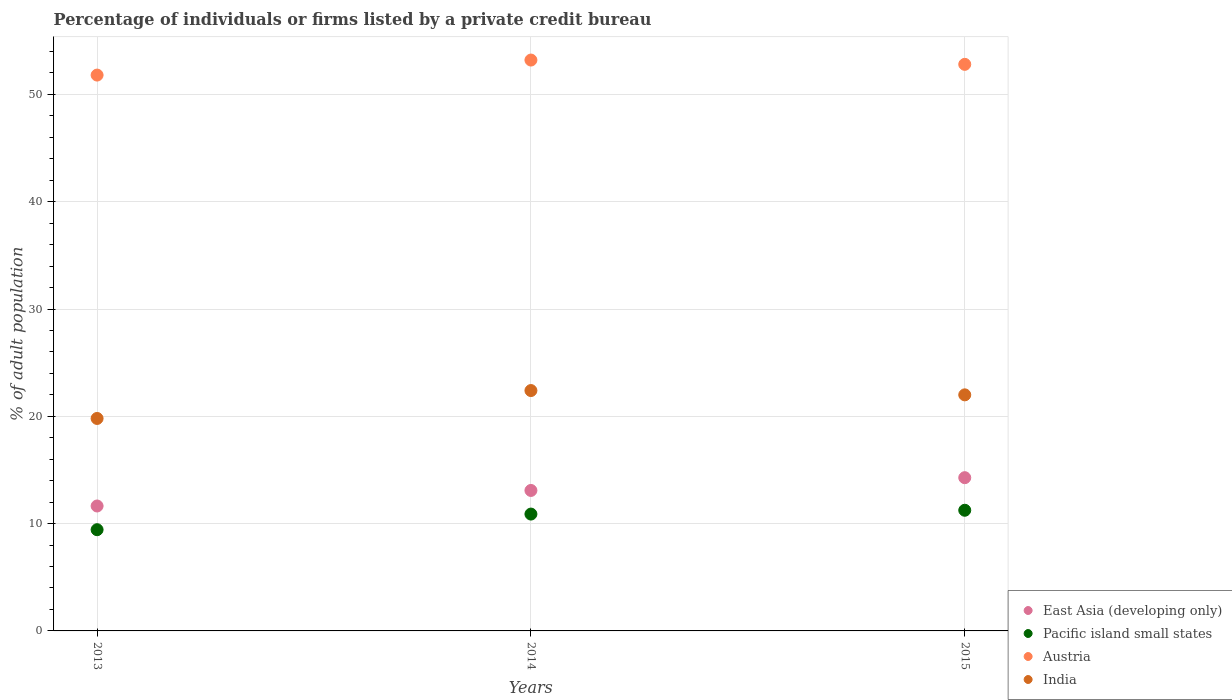Is the number of dotlines equal to the number of legend labels?
Your response must be concise. Yes. Across all years, what is the maximum percentage of population listed by a private credit bureau in Pacific island small states?
Provide a short and direct response. 11.24. Across all years, what is the minimum percentage of population listed by a private credit bureau in East Asia (developing only)?
Provide a succinct answer. 11.64. In which year was the percentage of population listed by a private credit bureau in East Asia (developing only) maximum?
Make the answer very short. 2015. What is the total percentage of population listed by a private credit bureau in India in the graph?
Keep it short and to the point. 64.2. What is the difference between the percentage of population listed by a private credit bureau in Austria in 2013 and that in 2014?
Ensure brevity in your answer.  -1.4. What is the difference between the percentage of population listed by a private credit bureau in Austria in 2015 and the percentage of population listed by a private credit bureau in Pacific island small states in 2014?
Provide a succinct answer. 41.91. What is the average percentage of population listed by a private credit bureau in India per year?
Your answer should be very brief. 21.4. In the year 2013, what is the difference between the percentage of population listed by a private credit bureau in East Asia (developing only) and percentage of population listed by a private credit bureau in Austria?
Offer a very short reply. -40.16. In how many years, is the percentage of population listed by a private credit bureau in Pacific island small states greater than 10 %?
Ensure brevity in your answer.  2. What is the ratio of the percentage of population listed by a private credit bureau in Pacific island small states in 2013 to that in 2014?
Make the answer very short. 0.87. Is the difference between the percentage of population listed by a private credit bureau in East Asia (developing only) in 2014 and 2015 greater than the difference between the percentage of population listed by a private credit bureau in Austria in 2014 and 2015?
Offer a terse response. No. What is the difference between the highest and the second highest percentage of population listed by a private credit bureau in East Asia (developing only)?
Make the answer very short. 1.19. What is the difference between the highest and the lowest percentage of population listed by a private credit bureau in Pacific island small states?
Offer a terse response. 1.81. Is it the case that in every year, the sum of the percentage of population listed by a private credit bureau in Austria and percentage of population listed by a private credit bureau in India  is greater than the percentage of population listed by a private credit bureau in East Asia (developing only)?
Provide a succinct answer. Yes. Does the percentage of population listed by a private credit bureau in India monotonically increase over the years?
Provide a succinct answer. No. Is the percentage of population listed by a private credit bureau in India strictly greater than the percentage of population listed by a private credit bureau in East Asia (developing only) over the years?
Ensure brevity in your answer.  Yes. How many years are there in the graph?
Provide a short and direct response. 3. What is the difference between two consecutive major ticks on the Y-axis?
Offer a terse response. 10. Are the values on the major ticks of Y-axis written in scientific E-notation?
Offer a very short reply. No. Does the graph contain any zero values?
Make the answer very short. No. Where does the legend appear in the graph?
Your answer should be very brief. Bottom right. What is the title of the graph?
Give a very brief answer. Percentage of individuals or firms listed by a private credit bureau. What is the label or title of the X-axis?
Your answer should be very brief. Years. What is the label or title of the Y-axis?
Your answer should be very brief. % of adult population. What is the % of adult population of East Asia (developing only) in 2013?
Your answer should be compact. 11.64. What is the % of adult population in Pacific island small states in 2013?
Your answer should be compact. 9.43. What is the % of adult population of Austria in 2013?
Make the answer very short. 51.8. What is the % of adult population of India in 2013?
Keep it short and to the point. 19.8. What is the % of adult population of East Asia (developing only) in 2014?
Your answer should be very brief. 13.09. What is the % of adult population in Pacific island small states in 2014?
Keep it short and to the point. 10.89. What is the % of adult population of Austria in 2014?
Keep it short and to the point. 53.2. What is the % of adult population of India in 2014?
Your answer should be very brief. 22.4. What is the % of adult population in East Asia (developing only) in 2015?
Give a very brief answer. 14.28. What is the % of adult population in Pacific island small states in 2015?
Offer a very short reply. 11.24. What is the % of adult population of Austria in 2015?
Offer a very short reply. 52.8. Across all years, what is the maximum % of adult population of East Asia (developing only)?
Provide a short and direct response. 14.28. Across all years, what is the maximum % of adult population of Pacific island small states?
Your answer should be compact. 11.24. Across all years, what is the maximum % of adult population in Austria?
Your answer should be compact. 53.2. Across all years, what is the maximum % of adult population in India?
Keep it short and to the point. 22.4. Across all years, what is the minimum % of adult population in East Asia (developing only)?
Keep it short and to the point. 11.64. Across all years, what is the minimum % of adult population in Pacific island small states?
Offer a terse response. 9.43. Across all years, what is the minimum % of adult population of Austria?
Offer a terse response. 51.8. Across all years, what is the minimum % of adult population of India?
Provide a succinct answer. 19.8. What is the total % of adult population in East Asia (developing only) in the graph?
Ensure brevity in your answer.  39.01. What is the total % of adult population of Pacific island small states in the graph?
Your response must be concise. 31.57. What is the total % of adult population of Austria in the graph?
Your response must be concise. 157.8. What is the total % of adult population in India in the graph?
Offer a very short reply. 64.2. What is the difference between the % of adult population in East Asia (developing only) in 2013 and that in 2014?
Provide a succinct answer. -1.45. What is the difference between the % of adult population in Pacific island small states in 2013 and that in 2014?
Offer a very short reply. -1.46. What is the difference between the % of adult population in Austria in 2013 and that in 2014?
Offer a terse response. -1.4. What is the difference between the % of adult population in East Asia (developing only) in 2013 and that in 2015?
Your answer should be very brief. -2.64. What is the difference between the % of adult population in Pacific island small states in 2013 and that in 2015?
Make the answer very short. -1.81. What is the difference between the % of adult population of East Asia (developing only) in 2014 and that in 2015?
Provide a short and direct response. -1.19. What is the difference between the % of adult population of Pacific island small states in 2014 and that in 2015?
Provide a short and direct response. -0.36. What is the difference between the % of adult population of East Asia (developing only) in 2013 and the % of adult population of Pacific island small states in 2014?
Offer a very short reply. 0.75. What is the difference between the % of adult population in East Asia (developing only) in 2013 and the % of adult population in Austria in 2014?
Make the answer very short. -41.56. What is the difference between the % of adult population of East Asia (developing only) in 2013 and the % of adult population of India in 2014?
Make the answer very short. -10.76. What is the difference between the % of adult population of Pacific island small states in 2013 and the % of adult population of Austria in 2014?
Your response must be concise. -43.77. What is the difference between the % of adult population of Pacific island small states in 2013 and the % of adult population of India in 2014?
Ensure brevity in your answer.  -12.97. What is the difference between the % of adult population in Austria in 2013 and the % of adult population in India in 2014?
Ensure brevity in your answer.  29.4. What is the difference between the % of adult population in East Asia (developing only) in 2013 and the % of adult population in Pacific island small states in 2015?
Your response must be concise. 0.4. What is the difference between the % of adult population of East Asia (developing only) in 2013 and the % of adult population of Austria in 2015?
Offer a very short reply. -41.16. What is the difference between the % of adult population in East Asia (developing only) in 2013 and the % of adult population in India in 2015?
Give a very brief answer. -10.36. What is the difference between the % of adult population in Pacific island small states in 2013 and the % of adult population in Austria in 2015?
Offer a very short reply. -43.37. What is the difference between the % of adult population in Pacific island small states in 2013 and the % of adult population in India in 2015?
Provide a short and direct response. -12.57. What is the difference between the % of adult population of Austria in 2013 and the % of adult population of India in 2015?
Keep it short and to the point. 29.8. What is the difference between the % of adult population in East Asia (developing only) in 2014 and the % of adult population in Pacific island small states in 2015?
Your response must be concise. 1.85. What is the difference between the % of adult population in East Asia (developing only) in 2014 and the % of adult population in Austria in 2015?
Offer a terse response. -39.71. What is the difference between the % of adult population of East Asia (developing only) in 2014 and the % of adult population of India in 2015?
Keep it short and to the point. -8.91. What is the difference between the % of adult population of Pacific island small states in 2014 and the % of adult population of Austria in 2015?
Your answer should be very brief. -41.91. What is the difference between the % of adult population of Pacific island small states in 2014 and the % of adult population of India in 2015?
Keep it short and to the point. -11.11. What is the difference between the % of adult population in Austria in 2014 and the % of adult population in India in 2015?
Offer a terse response. 31.2. What is the average % of adult population in East Asia (developing only) per year?
Your response must be concise. 13. What is the average % of adult population in Pacific island small states per year?
Give a very brief answer. 10.52. What is the average % of adult population of Austria per year?
Provide a succinct answer. 52.6. What is the average % of adult population in India per year?
Your answer should be very brief. 21.4. In the year 2013, what is the difference between the % of adult population in East Asia (developing only) and % of adult population in Pacific island small states?
Your response must be concise. 2.21. In the year 2013, what is the difference between the % of adult population of East Asia (developing only) and % of adult population of Austria?
Your answer should be very brief. -40.16. In the year 2013, what is the difference between the % of adult population in East Asia (developing only) and % of adult population in India?
Your answer should be compact. -8.16. In the year 2013, what is the difference between the % of adult population in Pacific island small states and % of adult population in Austria?
Your response must be concise. -42.37. In the year 2013, what is the difference between the % of adult population in Pacific island small states and % of adult population in India?
Keep it short and to the point. -10.37. In the year 2014, what is the difference between the % of adult population in East Asia (developing only) and % of adult population in Pacific island small states?
Offer a very short reply. 2.2. In the year 2014, what is the difference between the % of adult population in East Asia (developing only) and % of adult population in Austria?
Offer a very short reply. -40.11. In the year 2014, what is the difference between the % of adult population in East Asia (developing only) and % of adult population in India?
Offer a very short reply. -9.31. In the year 2014, what is the difference between the % of adult population in Pacific island small states and % of adult population in Austria?
Make the answer very short. -42.31. In the year 2014, what is the difference between the % of adult population in Pacific island small states and % of adult population in India?
Your answer should be compact. -11.51. In the year 2014, what is the difference between the % of adult population in Austria and % of adult population in India?
Give a very brief answer. 30.8. In the year 2015, what is the difference between the % of adult population in East Asia (developing only) and % of adult population in Pacific island small states?
Give a very brief answer. 3.04. In the year 2015, what is the difference between the % of adult population of East Asia (developing only) and % of adult population of Austria?
Your response must be concise. -38.52. In the year 2015, what is the difference between the % of adult population of East Asia (developing only) and % of adult population of India?
Ensure brevity in your answer.  -7.72. In the year 2015, what is the difference between the % of adult population in Pacific island small states and % of adult population in Austria?
Provide a short and direct response. -41.56. In the year 2015, what is the difference between the % of adult population in Pacific island small states and % of adult population in India?
Provide a short and direct response. -10.76. In the year 2015, what is the difference between the % of adult population in Austria and % of adult population in India?
Offer a very short reply. 30.8. What is the ratio of the % of adult population of East Asia (developing only) in 2013 to that in 2014?
Your answer should be very brief. 0.89. What is the ratio of the % of adult population of Pacific island small states in 2013 to that in 2014?
Give a very brief answer. 0.87. What is the ratio of the % of adult population of Austria in 2013 to that in 2014?
Your answer should be compact. 0.97. What is the ratio of the % of adult population in India in 2013 to that in 2014?
Provide a succinct answer. 0.88. What is the ratio of the % of adult population in East Asia (developing only) in 2013 to that in 2015?
Offer a very short reply. 0.82. What is the ratio of the % of adult population in Pacific island small states in 2013 to that in 2015?
Offer a terse response. 0.84. What is the ratio of the % of adult population in Austria in 2013 to that in 2015?
Keep it short and to the point. 0.98. What is the ratio of the % of adult population of East Asia (developing only) in 2014 to that in 2015?
Provide a short and direct response. 0.92. What is the ratio of the % of adult population of Pacific island small states in 2014 to that in 2015?
Give a very brief answer. 0.97. What is the ratio of the % of adult population in Austria in 2014 to that in 2015?
Provide a succinct answer. 1.01. What is the ratio of the % of adult population of India in 2014 to that in 2015?
Your response must be concise. 1.02. What is the difference between the highest and the second highest % of adult population in East Asia (developing only)?
Provide a succinct answer. 1.19. What is the difference between the highest and the second highest % of adult population in Pacific island small states?
Your answer should be very brief. 0.36. What is the difference between the highest and the second highest % of adult population of India?
Make the answer very short. 0.4. What is the difference between the highest and the lowest % of adult population in East Asia (developing only)?
Give a very brief answer. 2.64. What is the difference between the highest and the lowest % of adult population of Pacific island small states?
Make the answer very short. 1.81. What is the difference between the highest and the lowest % of adult population of Austria?
Offer a very short reply. 1.4. 